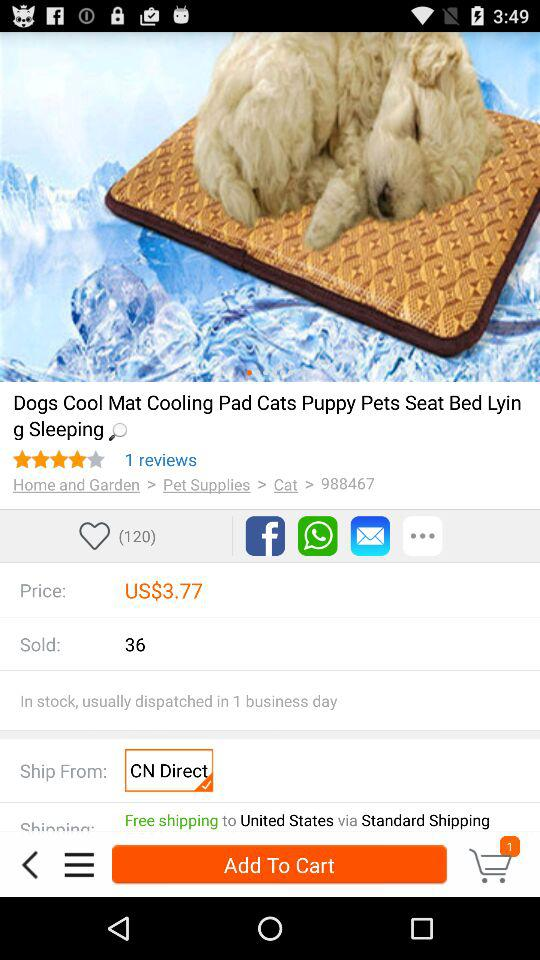How many reviews are there? There is 1 review. 